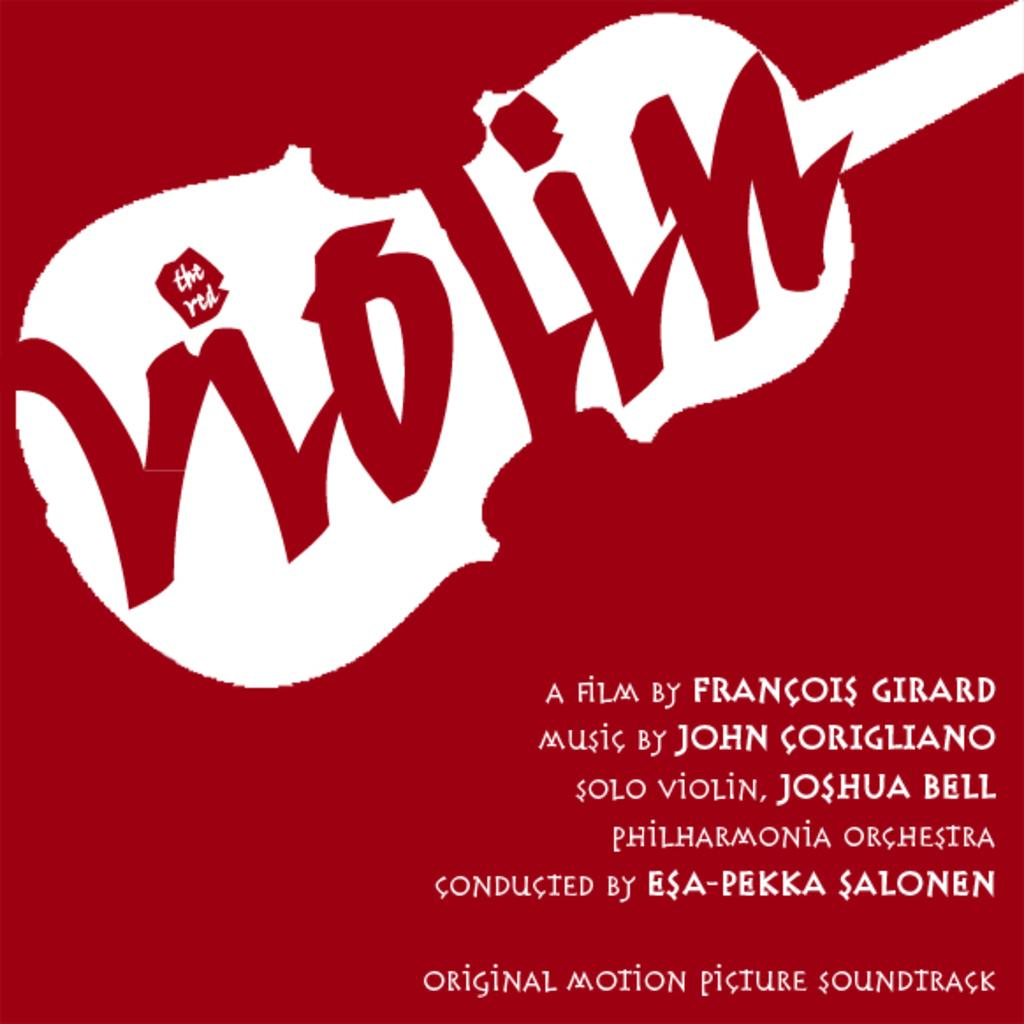<image>
Provide a brief description of the given image. The film Violin was made by Francois Girard, according to this poster. 